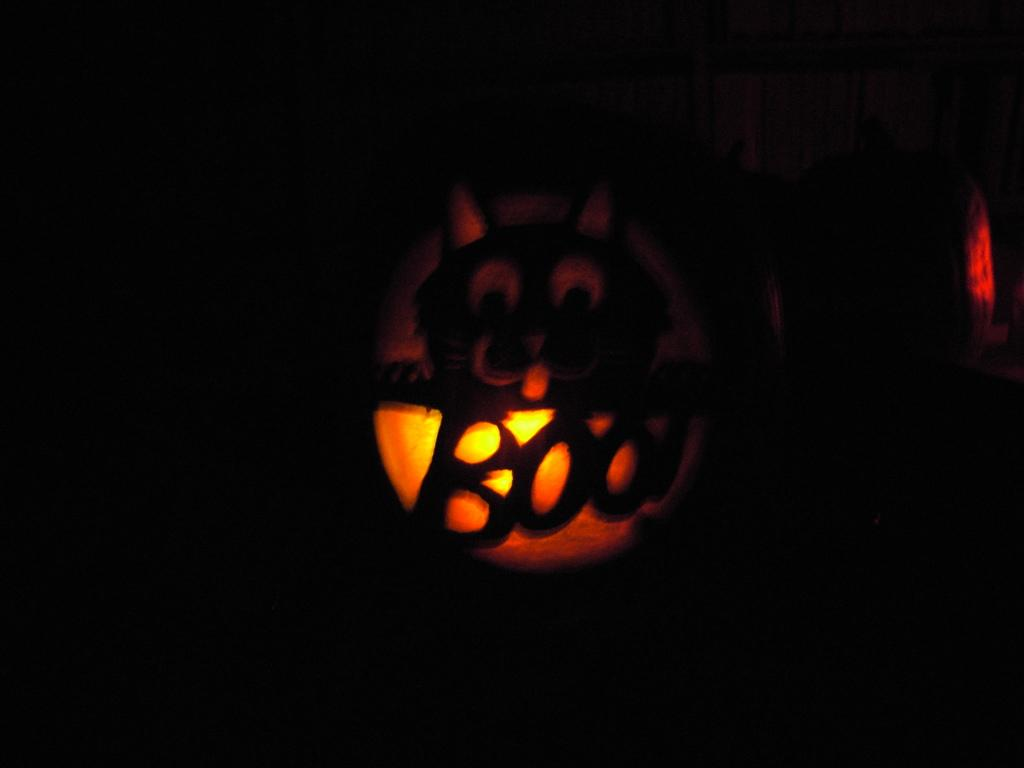What is the main source of light in the image? There is a light in the image. How would you describe the overall lighting in the image? The background of the image is dark. How many bones can be seen in the image? There are no bones present in the image. What type of ticket is visible in the image? There is no ticket present in the image. 